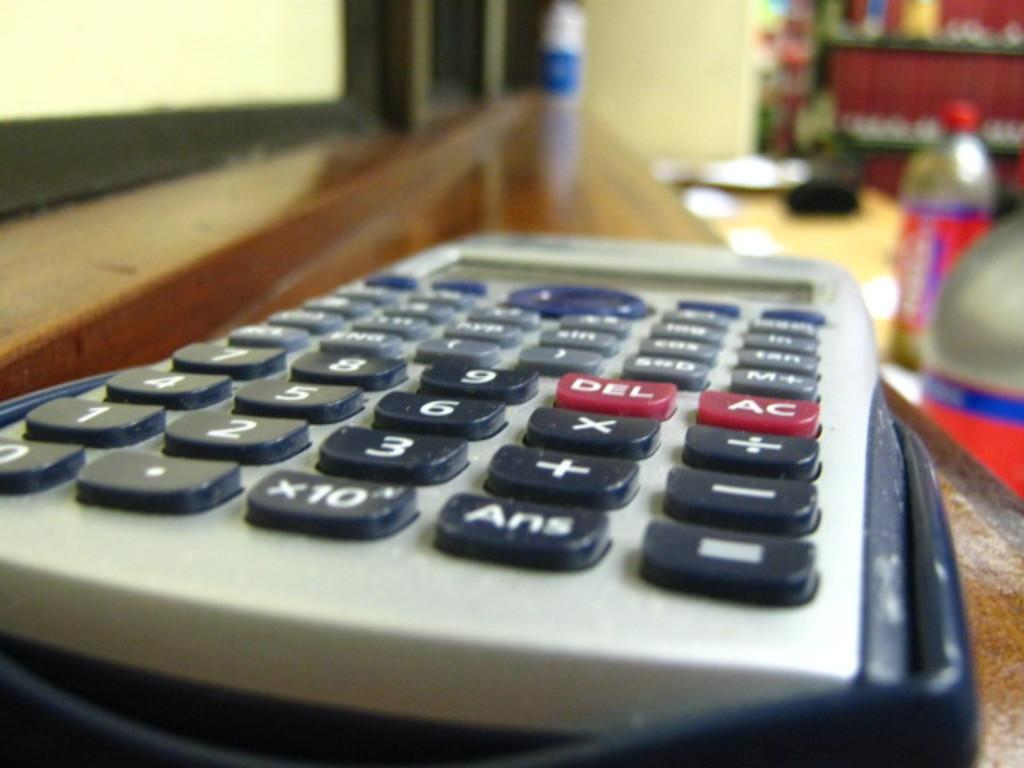<image>
Create a compact narrative representing the image presented. A calculator where the ans, del, and ac button can be seen. 